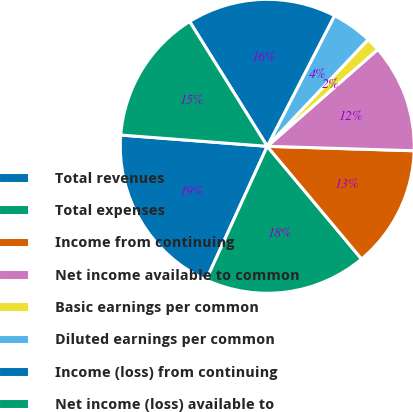Convert chart. <chart><loc_0><loc_0><loc_500><loc_500><pie_chart><fcel>Total revenues<fcel>Total expenses<fcel>Income from continuing<fcel>Net income available to common<fcel>Basic earnings per common<fcel>Diluted earnings per common<fcel>Income (loss) from continuing<fcel>Net income (loss) available to<nl><fcel>19.4%<fcel>17.91%<fcel>13.43%<fcel>11.94%<fcel>1.5%<fcel>4.48%<fcel>16.42%<fcel>14.92%<nl></chart> 